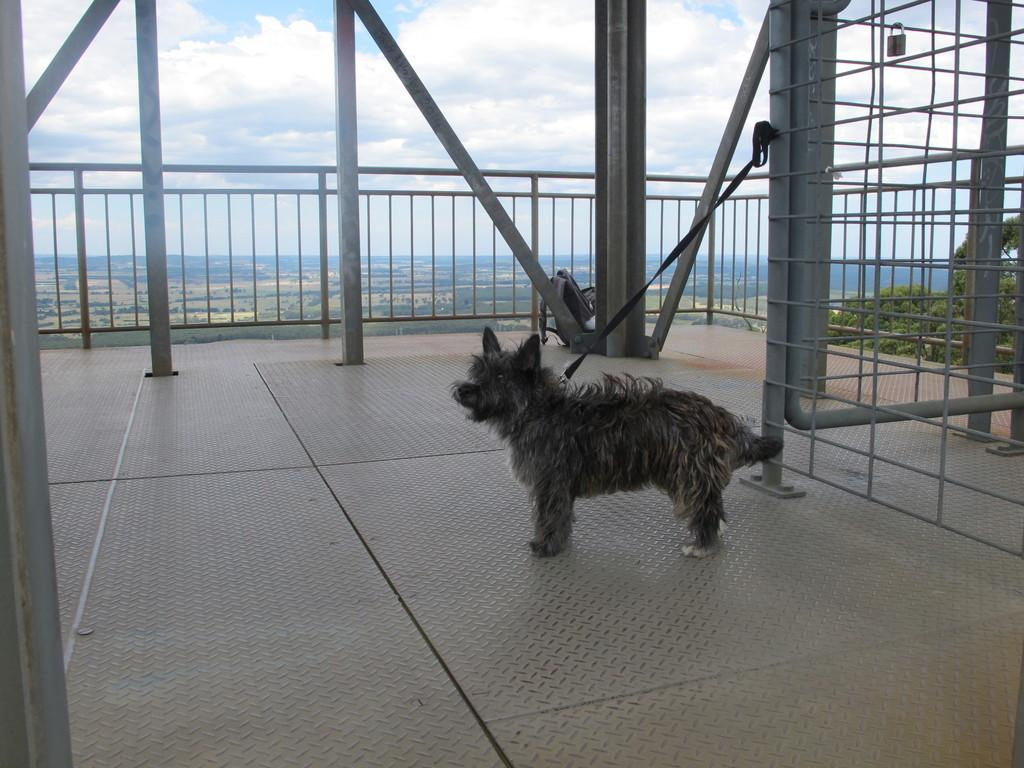What animal is present in the image? There is a dog in the image. How is the dog restrained in the image? The dog is tied to an object. What can be seen in the background of the image? There is a fence, poles, trees, and the sky visible in the background of the image. What type of notebook is the dog holding in the image? There is no notebook present in the image; it features a dog that is tied to an object. What color is the quilt that the dog is lying on in the image? There is no quilt present in the image, as the dog is standing and tied to an object. 